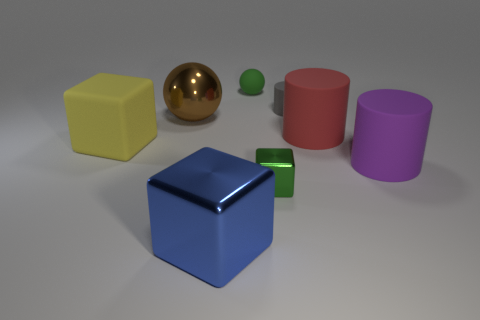The thing that is the same color as the rubber ball is what shape?
Keep it short and to the point. Cube. Are there any blue objects that have the same material as the big brown sphere?
Offer a terse response. Yes. There is a big object that is in front of the green shiny object; is its color the same as the metallic ball?
Your answer should be very brief. No. The matte sphere has what size?
Ensure brevity in your answer.  Small. Is there a big object that is behind the small green object in front of the cylinder that is in front of the large yellow thing?
Give a very brief answer. Yes. How many tiny green things are behind the small green rubber object?
Give a very brief answer. 0. What number of big shiny objects have the same color as the rubber block?
Offer a terse response. 0. What number of things are shiny things that are in front of the big purple matte cylinder or big things that are left of the tiny gray thing?
Give a very brief answer. 4. Is the number of cylinders greater than the number of things?
Make the answer very short. No. What color is the big rubber object that is on the left side of the tiny gray thing?
Offer a terse response. Yellow. 